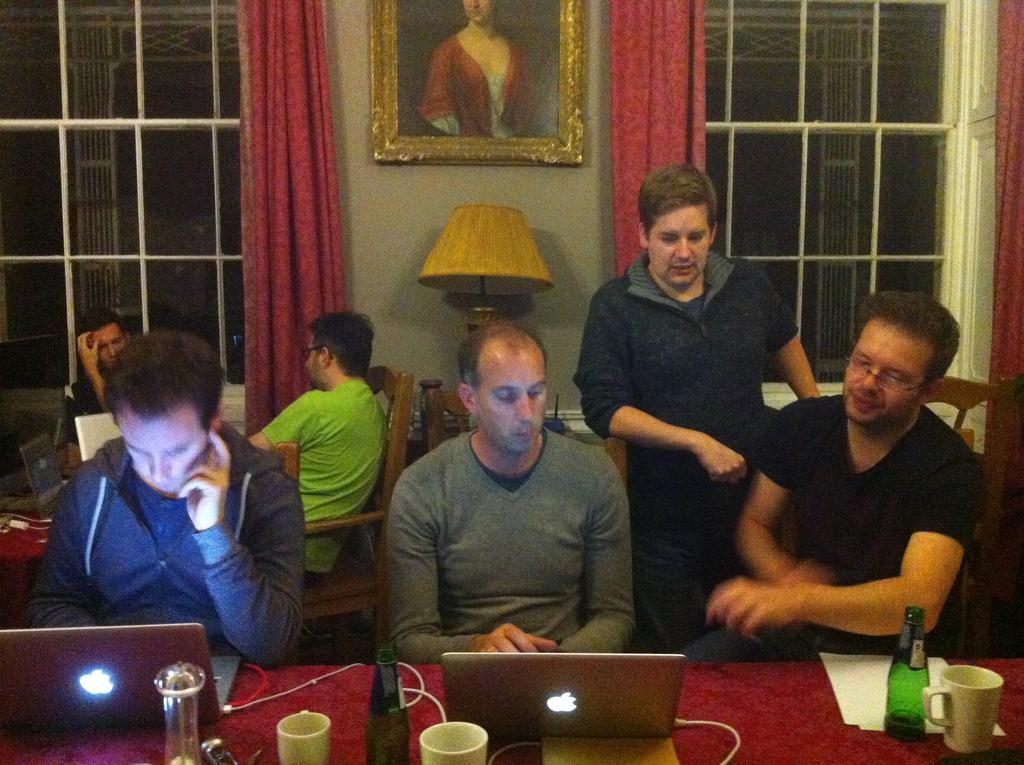How many men are in the image? There are several men in the image. What are the men doing in the image? The men are sitting on a table. What objects are on the table with the men? There are laptops on the table. What can be seen in the background of the image? There are glass windows and a painting in the background of the image. What type of nail is being used for arithmetic in the image? There is no nail or arithmetic activity present in the image. 